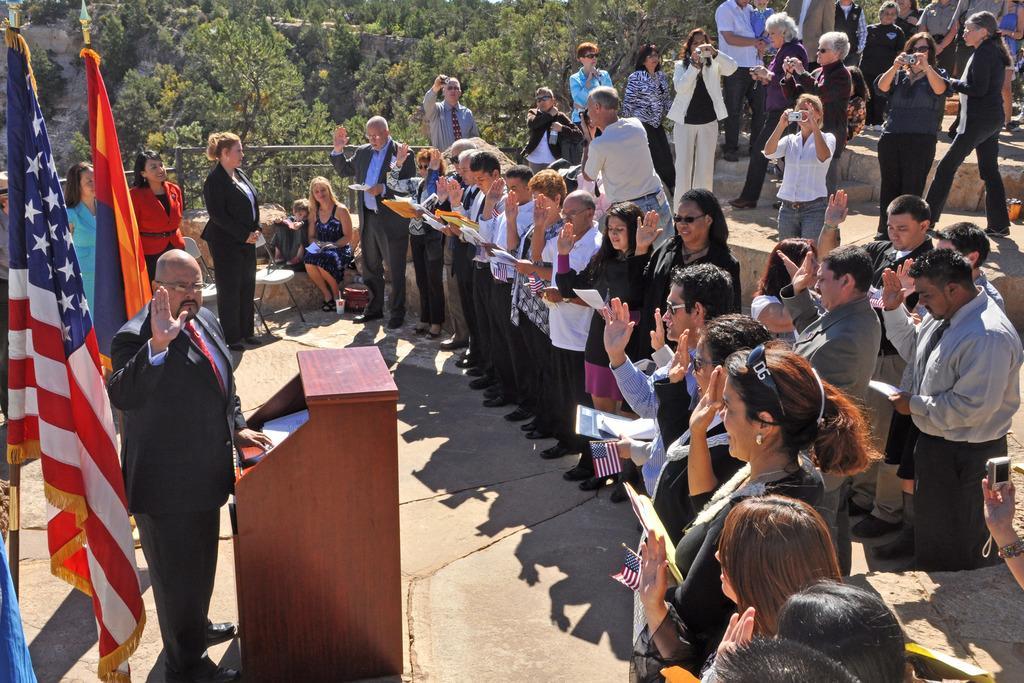Please provide a concise description of this image. In this picture we can see a group of people standing, flags, podium, papers, cameras, chairs and some objects and two people are sitting and in the background we can see trees. 